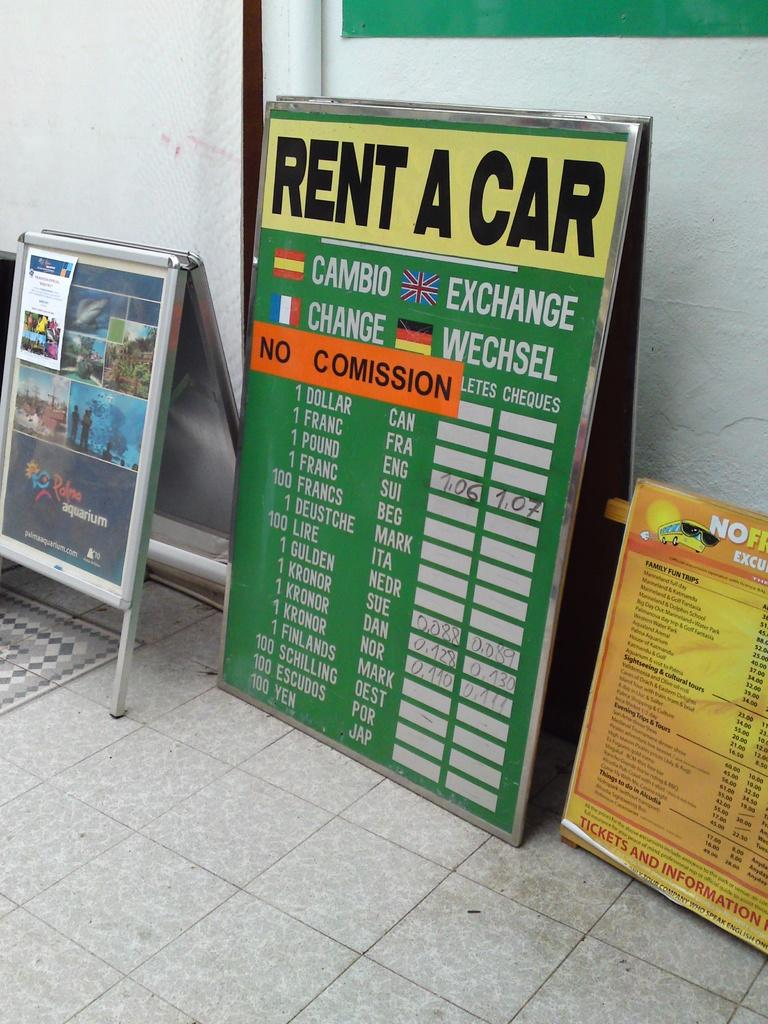<image>
Provide a brief description of the given image. A green sign with prices to rent a car 